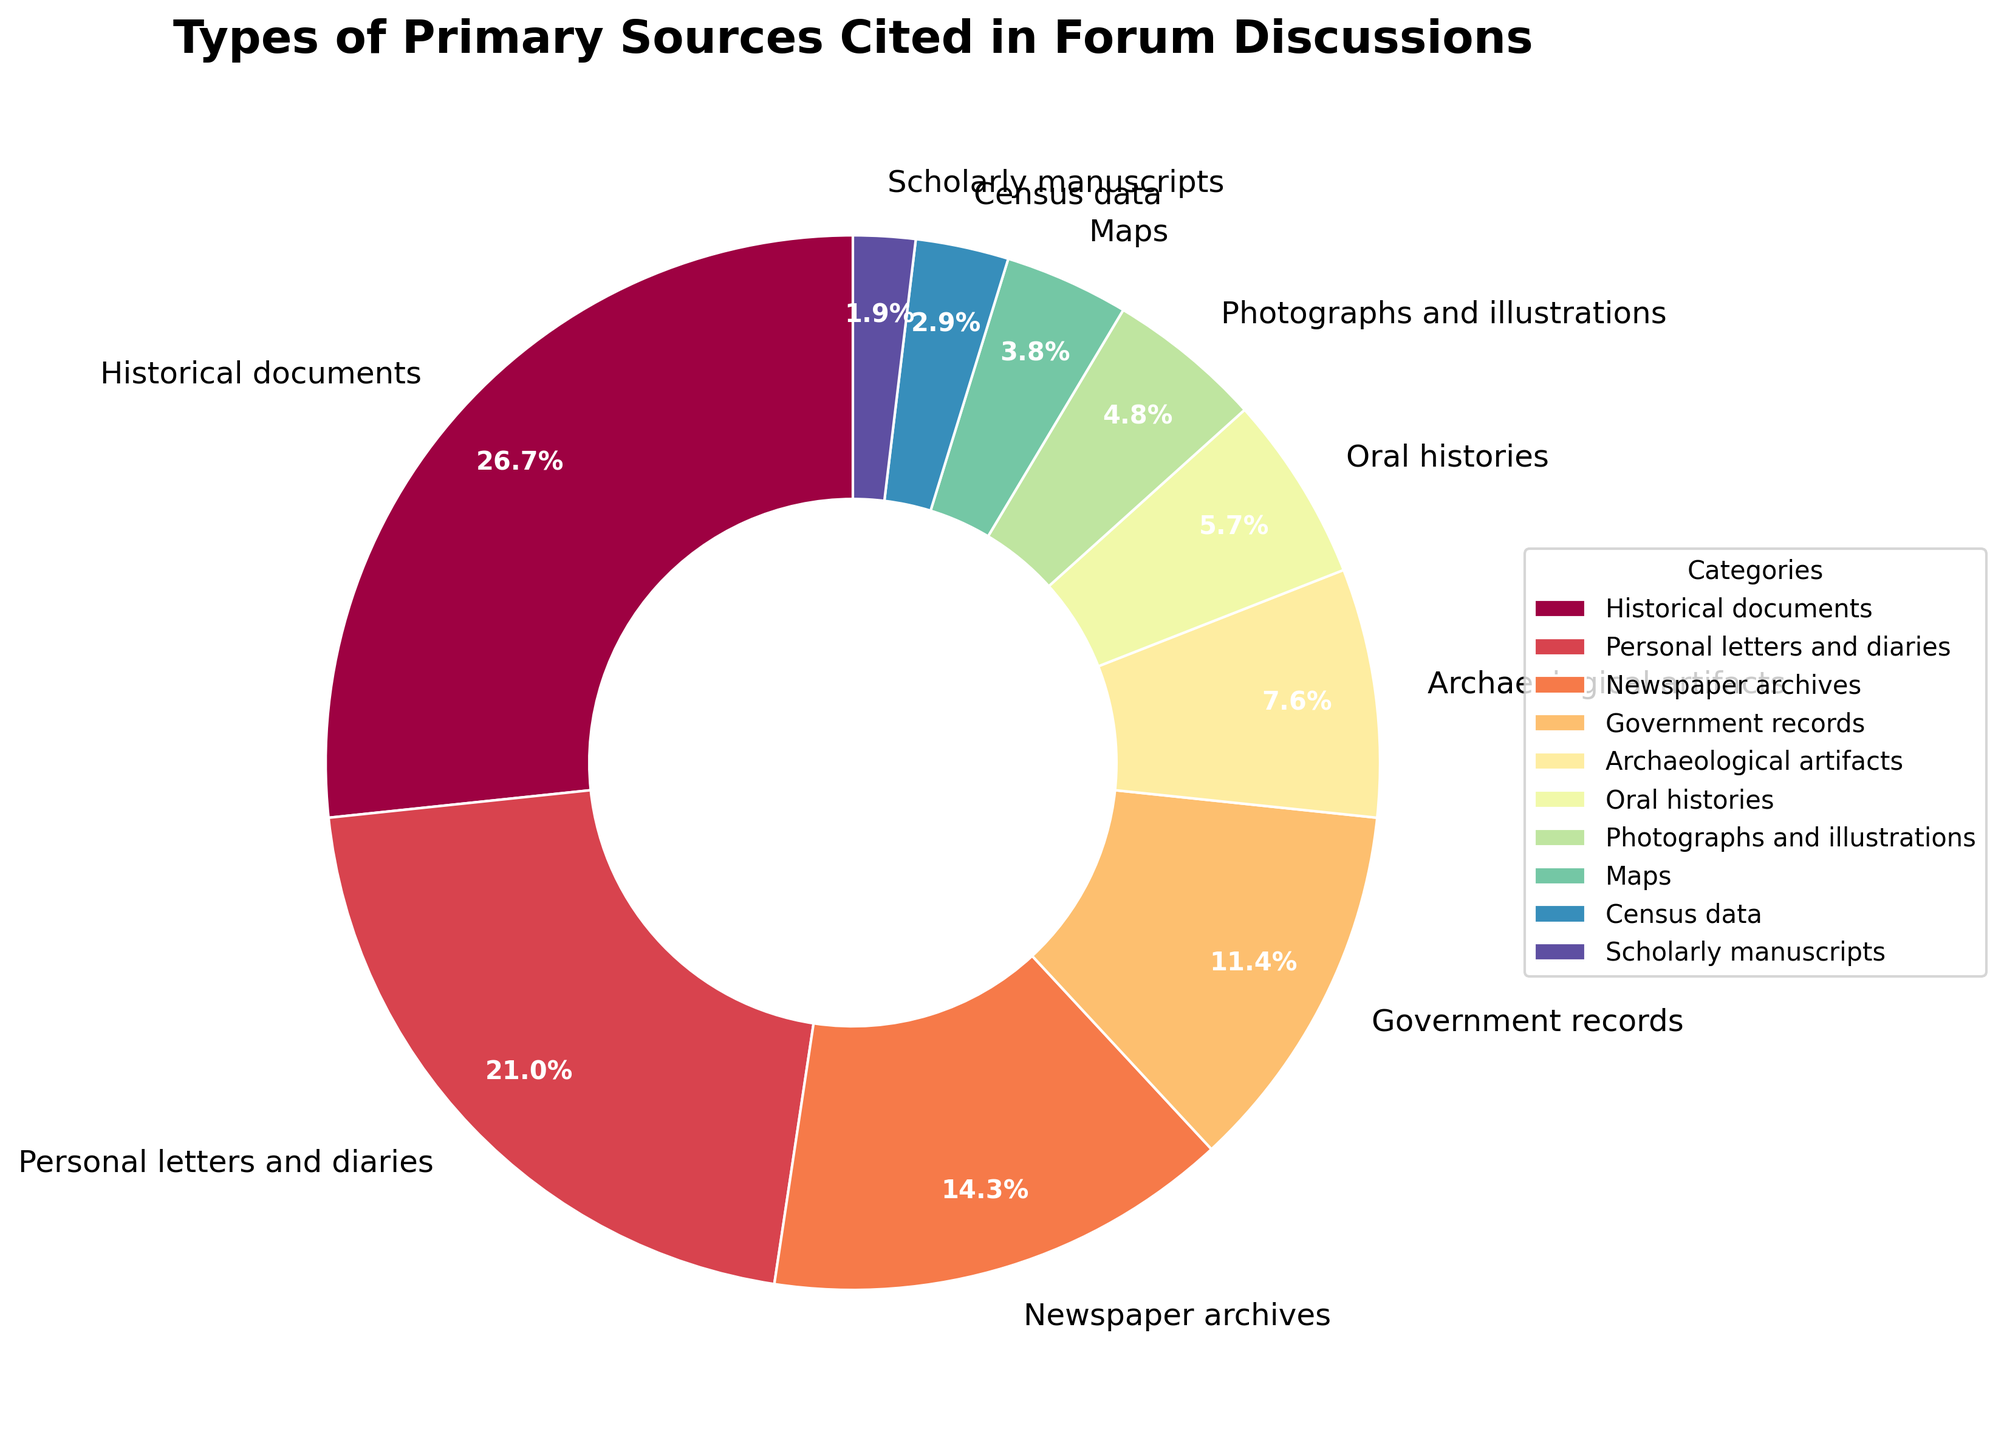What percentage of primary sources are historical documents compared to personal letters and diaries? Historical documents account for 28% of the primary sources cited, while personal letters and diaries account for 22%. To compare, 28% is higher than 22% by 6 percentage points.
Answer: 28% vs 22% What is the sum of the percentages for newspaper archives, government records, and maps? Newspaper archives account for 15%, government records for 12%, and maps for 4%. Summing them up: 15% + 12% + 4% = 31%.
Answer: 31% Which category has the lowest percentage, and what is its value? By examining the figure, scholarly manuscripts have the lowest percentage of primary sources cited, accounting for just 2%.
Answer: Scholarly manuscripts, 2% Are oral histories cited more frequently than photographs and illustrations? Oral histories are cited 6% of the time, while photographs and illustrations are cited 5%. Since 6% is greater than 5%, oral histories are cited more frequently.
Answer: Yes, oral histories are cited more frequently What's the combined percentage of categories with less than 10% each? The categories with less than 10% each are archaeological artifacts (8%), oral histories (6%), photographs and illustrations (5%), maps (4%), census data (3%), and scholarly manuscripts (2%). Summing these gives: 8% + 6% + 5% + 4% + 3% + 2% = 28%.
Answer: 28% Which category has the highest percentage in the pie chart? The highest percentage in the pie chart is for historical documents, which account for 28%.
Answer: Historical documents, 28% What is the percentage difference between archaeological artifacts and maps? Archaeological artifacts are 8% and maps are 4%. The difference is calculated as 8% - 4% = 4%.
Answer: 4% How do the combined percentages of photographs and illustrations, and maps compare to government records? Photographs and illustrations account for 5%, and maps for 4%. Combined, they are 5% + 4% = 9%. Government records alone account for 12%. Therefore, government records have a higher percentage.
Answer: Government records have a higher percentage Which categories together make up more than half of the cited primary sources? Historical documents (28%), personal letters and diaries (22%), and newspaper archives (15%) together account for 28% + 22% + 15% = 65%, which is more than half.
Answer: Historical documents, personal letters and diaries, and newspaper archives Between oral histories and census data, which has a greater percentage and by how much? Oral histories account for 6% while census data account for 3%. The difference is 6% - 3% = 3%.
Answer: Oral histories by 3% 